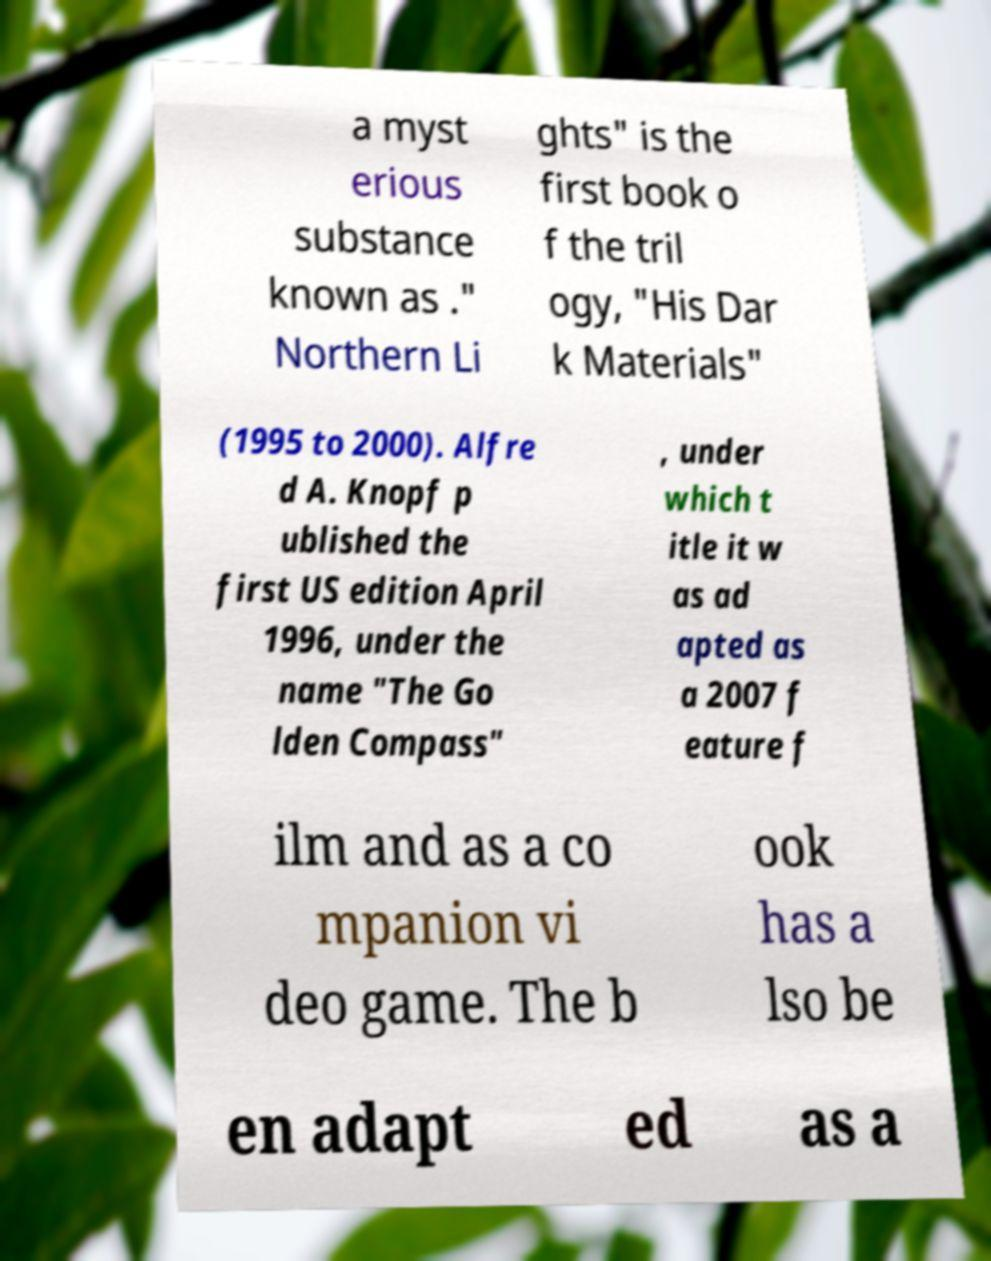Could you assist in decoding the text presented in this image and type it out clearly? a myst erious substance known as ." Northern Li ghts" is the first book o f the tril ogy, "His Dar k Materials" (1995 to 2000). Alfre d A. Knopf p ublished the first US edition April 1996, under the name "The Go lden Compass" , under which t itle it w as ad apted as a 2007 f eature f ilm and as a co mpanion vi deo game. The b ook has a lso be en adapt ed as a 